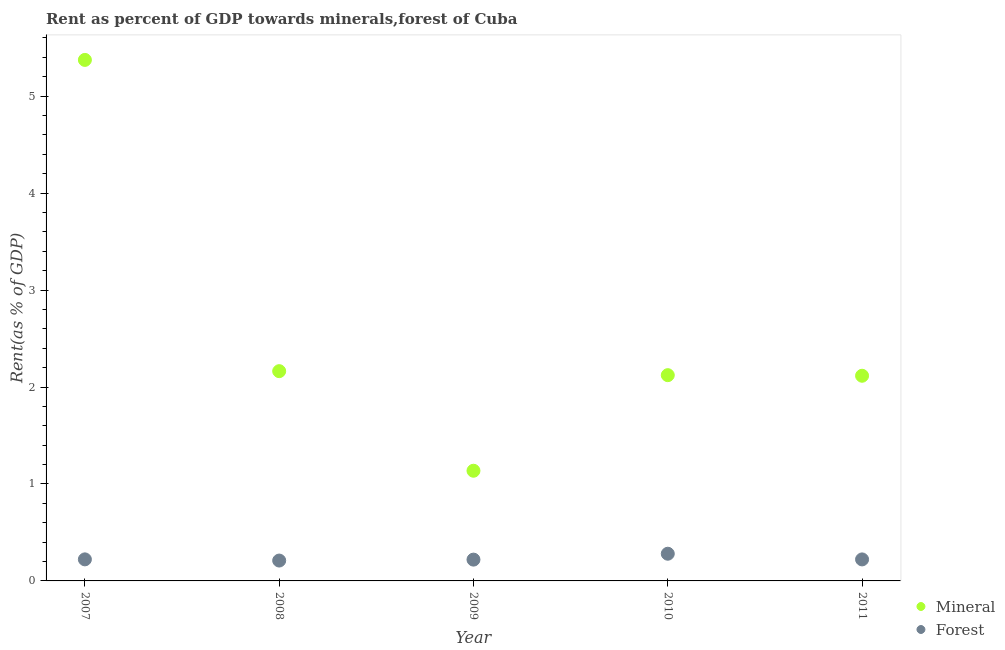How many different coloured dotlines are there?
Ensure brevity in your answer.  2. Is the number of dotlines equal to the number of legend labels?
Provide a short and direct response. Yes. What is the forest rent in 2010?
Ensure brevity in your answer.  0.28. Across all years, what is the maximum mineral rent?
Ensure brevity in your answer.  5.37. Across all years, what is the minimum mineral rent?
Your response must be concise. 1.14. In which year was the forest rent minimum?
Make the answer very short. 2008. What is the total mineral rent in the graph?
Offer a very short reply. 12.91. What is the difference between the mineral rent in 2007 and that in 2010?
Your response must be concise. 3.25. What is the difference between the forest rent in 2010 and the mineral rent in 2009?
Your answer should be very brief. -0.86. What is the average mineral rent per year?
Your answer should be very brief. 2.58. In the year 2010, what is the difference between the mineral rent and forest rent?
Your answer should be compact. 1.84. In how many years, is the mineral rent greater than 0.4 %?
Your answer should be compact. 5. What is the ratio of the forest rent in 2007 to that in 2011?
Keep it short and to the point. 1. What is the difference between the highest and the second highest mineral rent?
Give a very brief answer. 3.21. What is the difference between the highest and the lowest mineral rent?
Keep it short and to the point. 4.24. Is the sum of the forest rent in 2008 and 2010 greater than the maximum mineral rent across all years?
Provide a short and direct response. No. Does the mineral rent monotonically increase over the years?
Provide a short and direct response. No. Is the mineral rent strictly greater than the forest rent over the years?
Keep it short and to the point. Yes. Is the mineral rent strictly less than the forest rent over the years?
Offer a very short reply. No. What is the difference between two consecutive major ticks on the Y-axis?
Your answer should be compact. 1. Are the values on the major ticks of Y-axis written in scientific E-notation?
Your response must be concise. No. How are the legend labels stacked?
Provide a succinct answer. Vertical. What is the title of the graph?
Offer a very short reply. Rent as percent of GDP towards minerals,forest of Cuba. What is the label or title of the Y-axis?
Provide a short and direct response. Rent(as % of GDP). What is the Rent(as % of GDP) of Mineral in 2007?
Offer a very short reply. 5.37. What is the Rent(as % of GDP) of Forest in 2007?
Provide a succinct answer. 0.22. What is the Rent(as % of GDP) of Mineral in 2008?
Offer a very short reply. 2.16. What is the Rent(as % of GDP) of Forest in 2008?
Keep it short and to the point. 0.21. What is the Rent(as % of GDP) in Mineral in 2009?
Your answer should be very brief. 1.14. What is the Rent(as % of GDP) in Forest in 2009?
Your answer should be very brief. 0.22. What is the Rent(as % of GDP) of Mineral in 2010?
Provide a short and direct response. 2.12. What is the Rent(as % of GDP) in Forest in 2010?
Ensure brevity in your answer.  0.28. What is the Rent(as % of GDP) of Mineral in 2011?
Ensure brevity in your answer.  2.12. What is the Rent(as % of GDP) of Forest in 2011?
Offer a very short reply. 0.22. Across all years, what is the maximum Rent(as % of GDP) in Mineral?
Ensure brevity in your answer.  5.37. Across all years, what is the maximum Rent(as % of GDP) of Forest?
Offer a terse response. 0.28. Across all years, what is the minimum Rent(as % of GDP) of Mineral?
Your response must be concise. 1.14. Across all years, what is the minimum Rent(as % of GDP) in Forest?
Give a very brief answer. 0.21. What is the total Rent(as % of GDP) of Mineral in the graph?
Keep it short and to the point. 12.91. What is the total Rent(as % of GDP) of Forest in the graph?
Offer a terse response. 1.15. What is the difference between the Rent(as % of GDP) of Mineral in 2007 and that in 2008?
Give a very brief answer. 3.21. What is the difference between the Rent(as % of GDP) in Forest in 2007 and that in 2008?
Ensure brevity in your answer.  0.01. What is the difference between the Rent(as % of GDP) in Mineral in 2007 and that in 2009?
Provide a succinct answer. 4.24. What is the difference between the Rent(as % of GDP) of Forest in 2007 and that in 2009?
Offer a terse response. 0. What is the difference between the Rent(as % of GDP) of Mineral in 2007 and that in 2010?
Keep it short and to the point. 3.25. What is the difference between the Rent(as % of GDP) in Forest in 2007 and that in 2010?
Keep it short and to the point. -0.06. What is the difference between the Rent(as % of GDP) in Mineral in 2007 and that in 2011?
Ensure brevity in your answer.  3.26. What is the difference between the Rent(as % of GDP) in Mineral in 2008 and that in 2009?
Make the answer very short. 1.03. What is the difference between the Rent(as % of GDP) of Forest in 2008 and that in 2009?
Offer a terse response. -0.01. What is the difference between the Rent(as % of GDP) of Mineral in 2008 and that in 2010?
Provide a succinct answer. 0.04. What is the difference between the Rent(as % of GDP) of Forest in 2008 and that in 2010?
Offer a terse response. -0.07. What is the difference between the Rent(as % of GDP) of Mineral in 2008 and that in 2011?
Your answer should be very brief. 0.05. What is the difference between the Rent(as % of GDP) in Forest in 2008 and that in 2011?
Give a very brief answer. -0.01. What is the difference between the Rent(as % of GDP) in Mineral in 2009 and that in 2010?
Your answer should be compact. -0.99. What is the difference between the Rent(as % of GDP) in Forest in 2009 and that in 2010?
Provide a short and direct response. -0.06. What is the difference between the Rent(as % of GDP) of Mineral in 2009 and that in 2011?
Your answer should be very brief. -0.98. What is the difference between the Rent(as % of GDP) in Forest in 2009 and that in 2011?
Provide a short and direct response. -0. What is the difference between the Rent(as % of GDP) in Mineral in 2010 and that in 2011?
Provide a short and direct response. 0.01. What is the difference between the Rent(as % of GDP) in Forest in 2010 and that in 2011?
Ensure brevity in your answer.  0.06. What is the difference between the Rent(as % of GDP) in Mineral in 2007 and the Rent(as % of GDP) in Forest in 2008?
Your answer should be very brief. 5.16. What is the difference between the Rent(as % of GDP) of Mineral in 2007 and the Rent(as % of GDP) of Forest in 2009?
Your answer should be compact. 5.15. What is the difference between the Rent(as % of GDP) in Mineral in 2007 and the Rent(as % of GDP) in Forest in 2010?
Your answer should be very brief. 5.09. What is the difference between the Rent(as % of GDP) of Mineral in 2007 and the Rent(as % of GDP) of Forest in 2011?
Your answer should be very brief. 5.15. What is the difference between the Rent(as % of GDP) of Mineral in 2008 and the Rent(as % of GDP) of Forest in 2009?
Make the answer very short. 1.94. What is the difference between the Rent(as % of GDP) of Mineral in 2008 and the Rent(as % of GDP) of Forest in 2010?
Offer a very short reply. 1.88. What is the difference between the Rent(as % of GDP) in Mineral in 2008 and the Rent(as % of GDP) in Forest in 2011?
Offer a terse response. 1.94. What is the difference between the Rent(as % of GDP) of Mineral in 2009 and the Rent(as % of GDP) of Forest in 2010?
Make the answer very short. 0.86. What is the difference between the Rent(as % of GDP) in Mineral in 2009 and the Rent(as % of GDP) in Forest in 2011?
Keep it short and to the point. 0.91. What is the difference between the Rent(as % of GDP) of Mineral in 2010 and the Rent(as % of GDP) of Forest in 2011?
Your response must be concise. 1.9. What is the average Rent(as % of GDP) of Mineral per year?
Ensure brevity in your answer.  2.58. What is the average Rent(as % of GDP) in Forest per year?
Make the answer very short. 0.23. In the year 2007, what is the difference between the Rent(as % of GDP) in Mineral and Rent(as % of GDP) in Forest?
Give a very brief answer. 5.15. In the year 2008, what is the difference between the Rent(as % of GDP) in Mineral and Rent(as % of GDP) in Forest?
Your answer should be very brief. 1.95. In the year 2009, what is the difference between the Rent(as % of GDP) of Mineral and Rent(as % of GDP) of Forest?
Provide a short and direct response. 0.92. In the year 2010, what is the difference between the Rent(as % of GDP) of Mineral and Rent(as % of GDP) of Forest?
Ensure brevity in your answer.  1.84. In the year 2011, what is the difference between the Rent(as % of GDP) of Mineral and Rent(as % of GDP) of Forest?
Provide a short and direct response. 1.89. What is the ratio of the Rent(as % of GDP) in Mineral in 2007 to that in 2008?
Keep it short and to the point. 2.48. What is the ratio of the Rent(as % of GDP) in Forest in 2007 to that in 2008?
Keep it short and to the point. 1.06. What is the ratio of the Rent(as % of GDP) in Mineral in 2007 to that in 2009?
Ensure brevity in your answer.  4.73. What is the ratio of the Rent(as % of GDP) in Forest in 2007 to that in 2009?
Offer a terse response. 1.01. What is the ratio of the Rent(as % of GDP) of Mineral in 2007 to that in 2010?
Offer a very short reply. 2.53. What is the ratio of the Rent(as % of GDP) of Forest in 2007 to that in 2010?
Offer a terse response. 0.79. What is the ratio of the Rent(as % of GDP) in Mineral in 2007 to that in 2011?
Give a very brief answer. 2.54. What is the ratio of the Rent(as % of GDP) in Mineral in 2008 to that in 2009?
Make the answer very short. 1.9. What is the ratio of the Rent(as % of GDP) of Forest in 2008 to that in 2009?
Your answer should be compact. 0.96. What is the ratio of the Rent(as % of GDP) of Mineral in 2008 to that in 2010?
Your answer should be compact. 1.02. What is the ratio of the Rent(as % of GDP) in Forest in 2008 to that in 2010?
Your response must be concise. 0.75. What is the ratio of the Rent(as % of GDP) in Mineral in 2008 to that in 2011?
Make the answer very short. 1.02. What is the ratio of the Rent(as % of GDP) in Forest in 2008 to that in 2011?
Offer a very short reply. 0.95. What is the ratio of the Rent(as % of GDP) of Mineral in 2009 to that in 2010?
Give a very brief answer. 0.54. What is the ratio of the Rent(as % of GDP) of Forest in 2009 to that in 2010?
Give a very brief answer. 0.78. What is the ratio of the Rent(as % of GDP) in Mineral in 2009 to that in 2011?
Provide a short and direct response. 0.54. What is the ratio of the Rent(as % of GDP) of Forest in 2009 to that in 2011?
Keep it short and to the point. 0.99. What is the ratio of the Rent(as % of GDP) in Mineral in 2010 to that in 2011?
Keep it short and to the point. 1. What is the ratio of the Rent(as % of GDP) in Forest in 2010 to that in 2011?
Offer a very short reply. 1.26. What is the difference between the highest and the second highest Rent(as % of GDP) in Mineral?
Your response must be concise. 3.21. What is the difference between the highest and the second highest Rent(as % of GDP) in Forest?
Provide a succinct answer. 0.06. What is the difference between the highest and the lowest Rent(as % of GDP) in Mineral?
Ensure brevity in your answer.  4.24. What is the difference between the highest and the lowest Rent(as % of GDP) of Forest?
Your response must be concise. 0.07. 